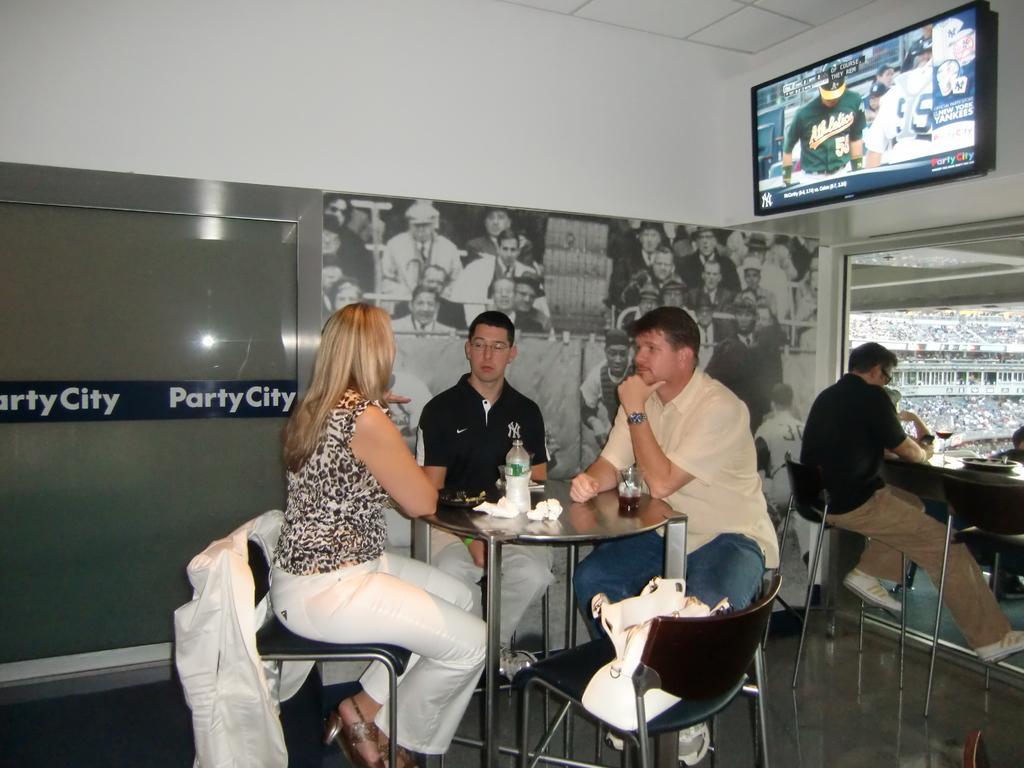In one or two sentences, can you explain what this image depicts? In this picture three people are sitting in round table and food items are on top of it. In the background we observe a television fitted to the wall and a guy is sitting on the table. The picture is clicked inside a stadium. 